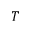<formula> <loc_0><loc_0><loc_500><loc_500>T</formula> 